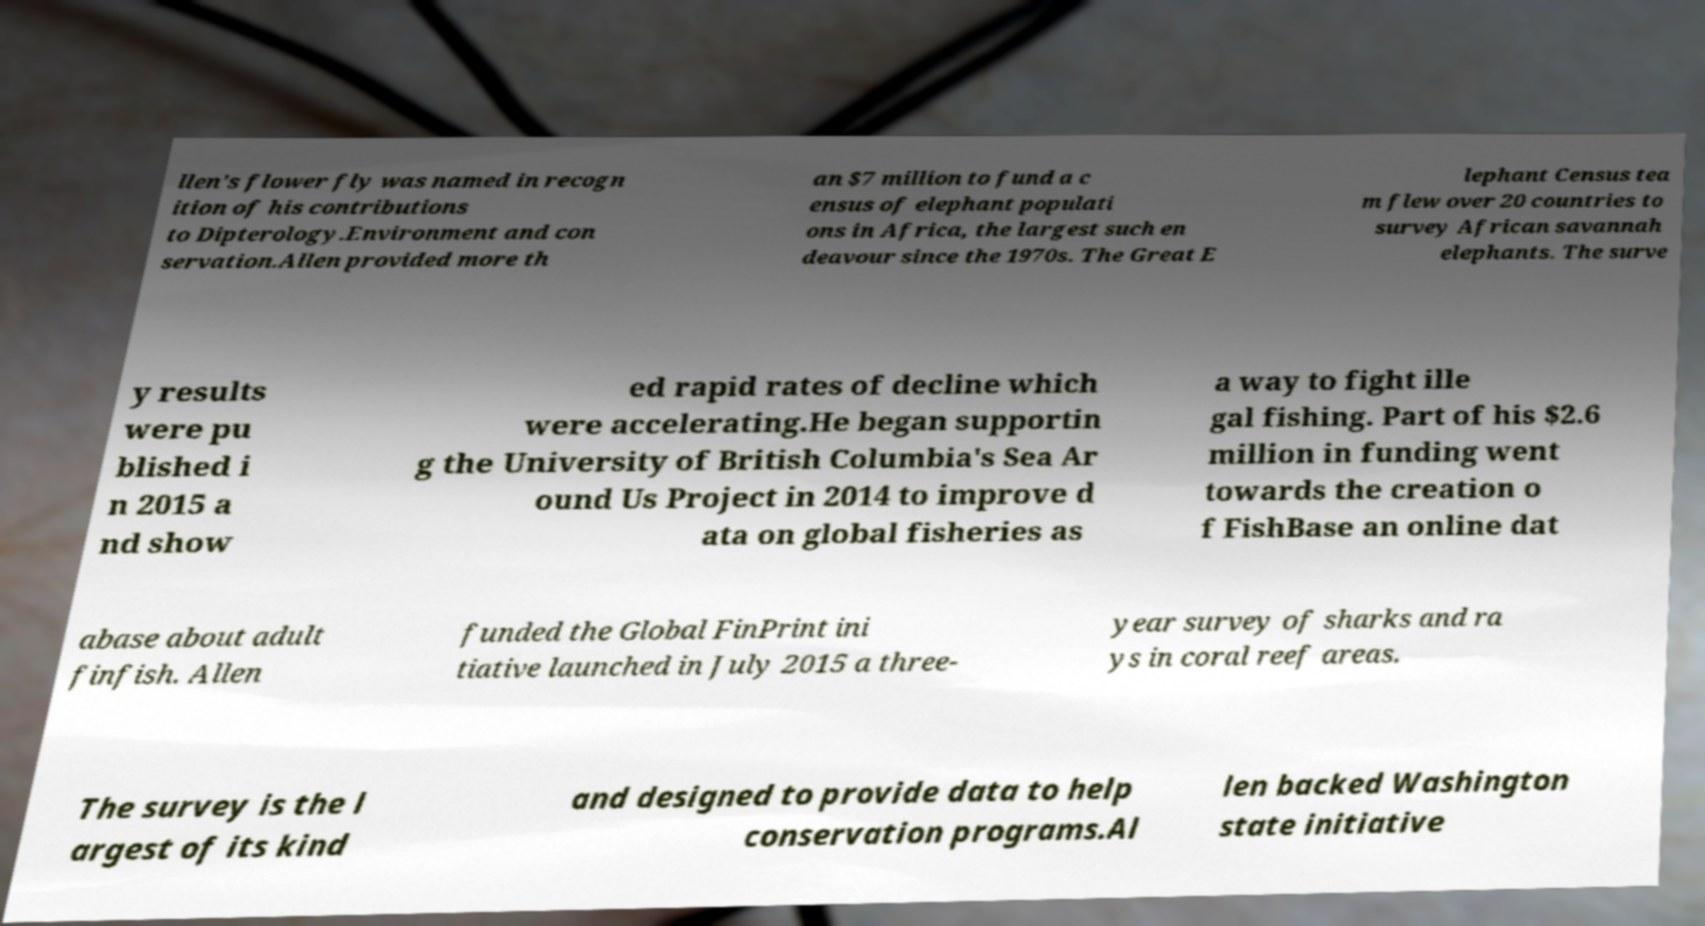Can you accurately transcribe the text from the provided image for me? llen's flower fly was named in recogn ition of his contributions to Dipterology.Environment and con servation.Allen provided more th an $7 million to fund a c ensus of elephant populati ons in Africa, the largest such en deavour since the 1970s. The Great E lephant Census tea m flew over 20 countries to survey African savannah elephants. The surve y results were pu blished i n 2015 a nd show ed rapid rates of decline which were accelerating.He began supportin g the University of British Columbia's Sea Ar ound Us Project in 2014 to improve d ata on global fisheries as a way to fight ille gal fishing. Part of his $2.6 million in funding went towards the creation o f FishBase an online dat abase about adult finfish. Allen funded the Global FinPrint ini tiative launched in July 2015 a three- year survey of sharks and ra ys in coral reef areas. The survey is the l argest of its kind and designed to provide data to help conservation programs.Al len backed Washington state initiative 